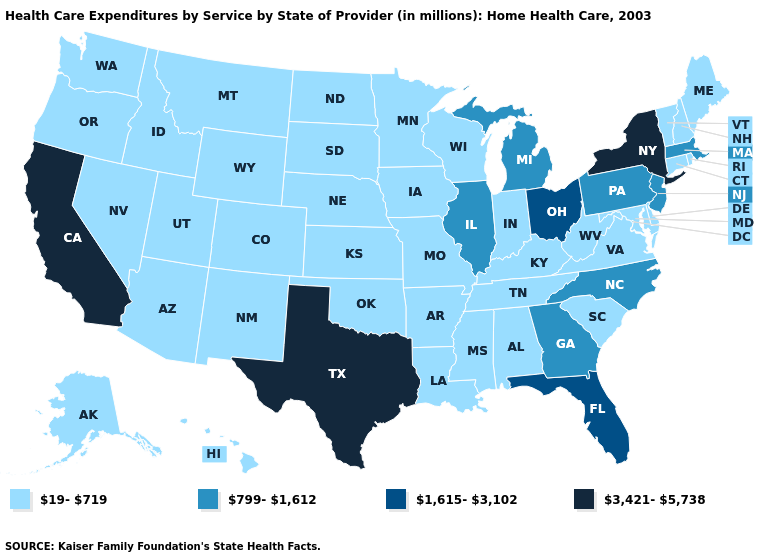Does Ohio have the highest value in the MidWest?
Quick response, please. Yes. Name the states that have a value in the range 3,421-5,738?
Write a very short answer. California, New York, Texas. Among the states that border New Jersey , which have the lowest value?
Quick response, please. Delaware. Does New Hampshire have a lower value than Texas?
Short answer required. Yes. What is the value of Maine?
Write a very short answer. 19-719. How many symbols are there in the legend?
Quick response, please. 4. Name the states that have a value in the range 1,615-3,102?
Short answer required. Florida, Ohio. How many symbols are there in the legend?
Write a very short answer. 4. Does Texas have the highest value in the USA?
Concise answer only. Yes. Does Idaho have a higher value than North Dakota?
Short answer required. No. What is the highest value in the South ?
Answer briefly. 3,421-5,738. Which states hav the highest value in the MidWest?
Write a very short answer. Ohio. What is the highest value in states that border Vermont?
Answer briefly. 3,421-5,738. How many symbols are there in the legend?
Concise answer only. 4. Name the states that have a value in the range 3,421-5,738?
Answer briefly. California, New York, Texas. 